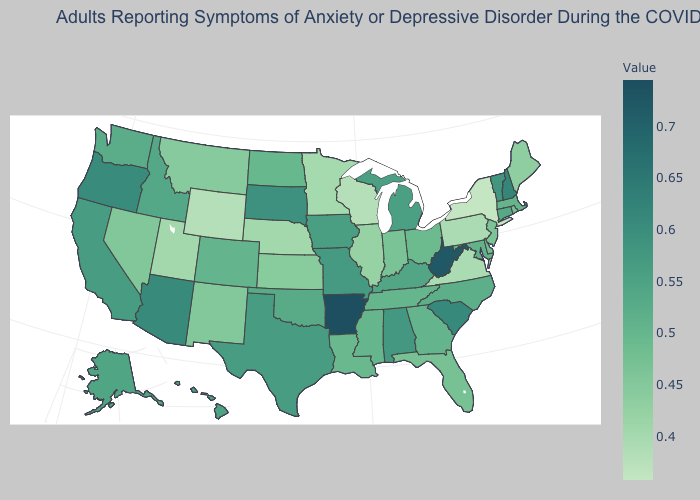Does the map have missing data?
Give a very brief answer. No. Does Kansas have the lowest value in the MidWest?
Keep it brief. No. Among the states that border Washington , which have the lowest value?
Quick response, please. Idaho. Among the states that border Montana , does Idaho have the lowest value?
Short answer required. No. 